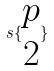Convert formula to latex. <formula><loc_0><loc_0><loc_500><loc_500>s \{ \begin{matrix} p \\ 2 \end{matrix} \}</formula> 